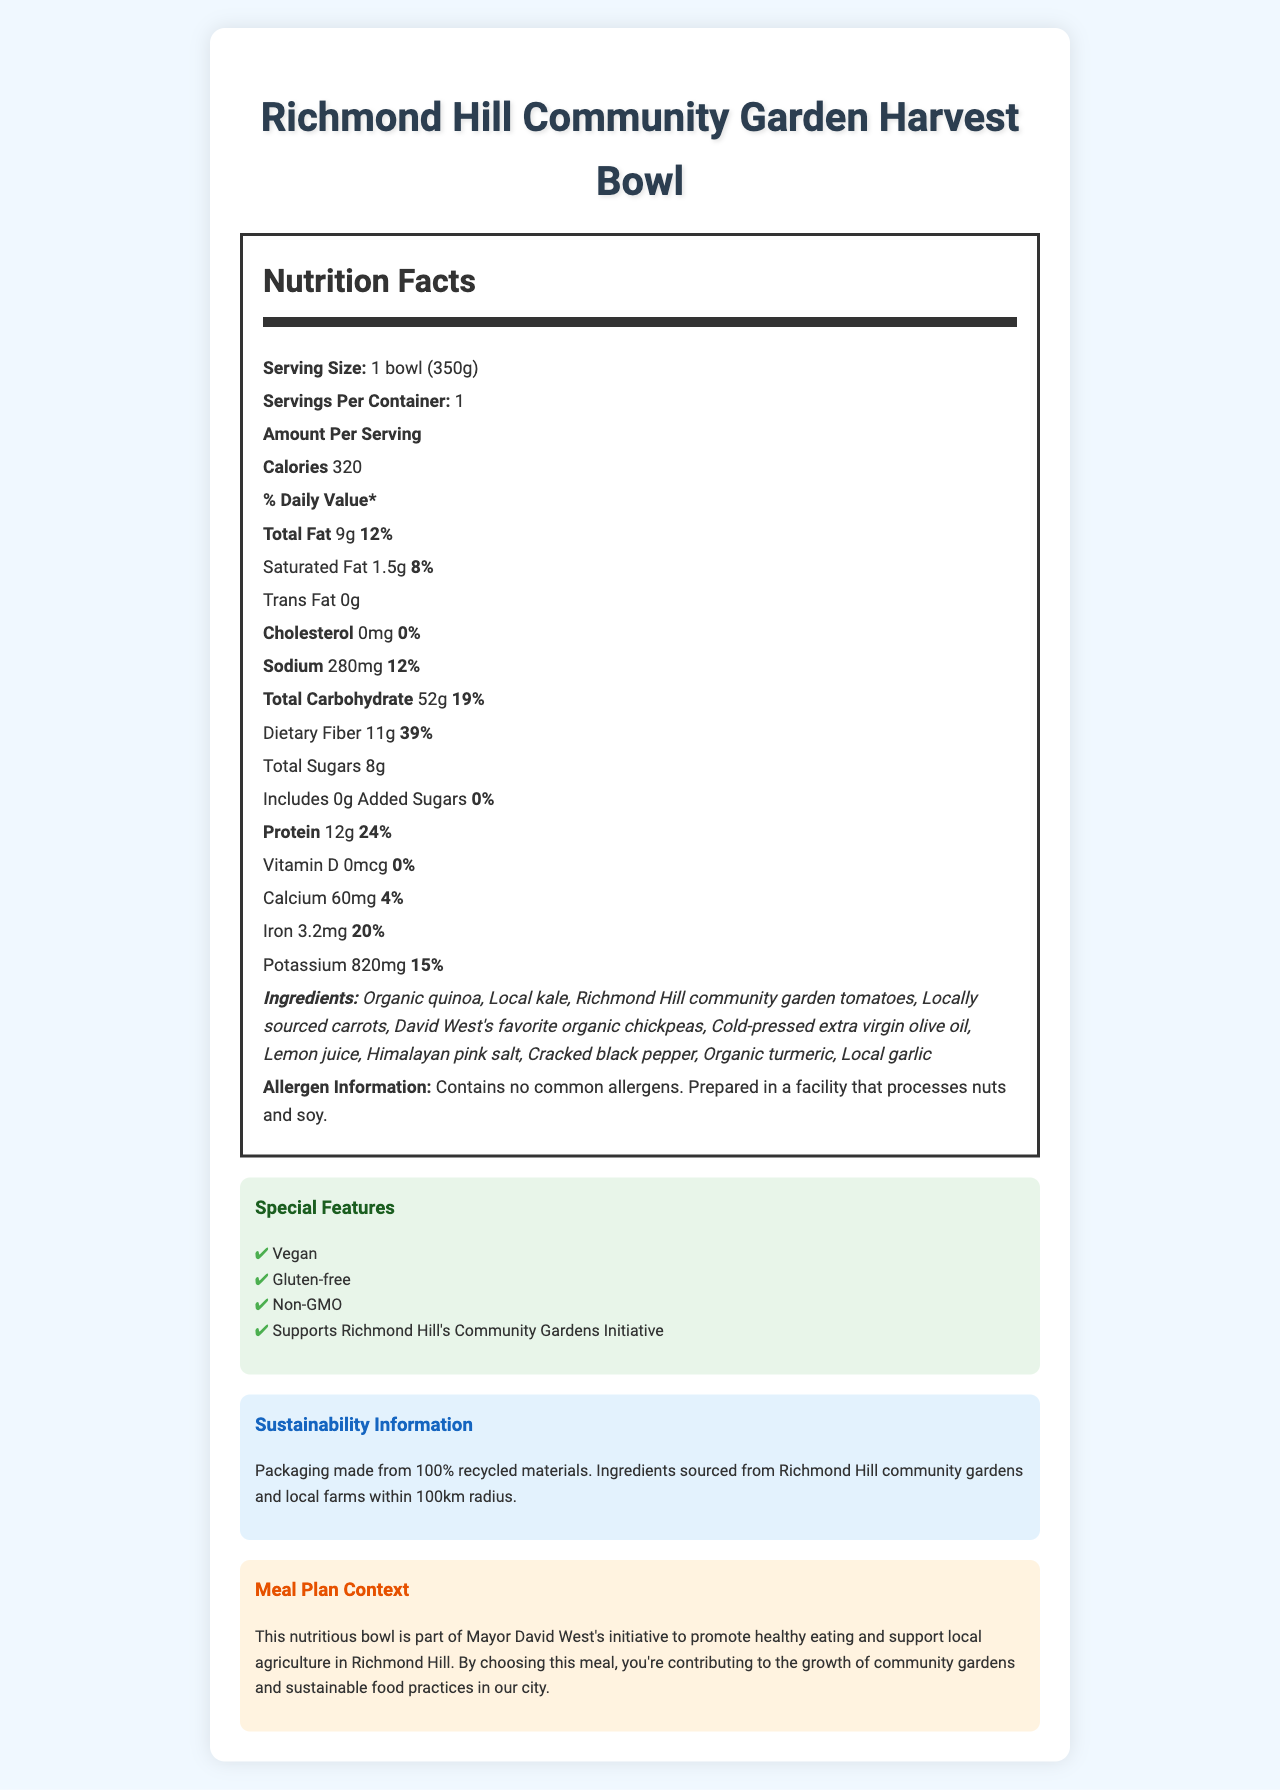what is the serving size for the Richmond Hill Community Garden Harvest Bowl? The serving size is listed in the nutrition facts section as "1 bowl (350g)".
Answer: 1 bowl (350g) how many calories are in one serving of the Harvest Bowl? The number of calories is stated as 320 in the nutrition facts.
Answer: 320 what percentage of the daily value of dietary fiber does one serving of the Harvest Bowl provide? The nutrition facts label indicates that the dietary fiber daily value percentage is 39%.
Answer: 39% list three ingredients used in the Harvest Bowl. Three of the listed ingredients are Organic quinoa, Local kale, and Richmond Hill community garden tomatoes.
Answer: Organic quinoa, Local kale, Richmond Hill community garden tomatoes what is the total carbohydrate content in one serving? The nutrition facts state that one serving contains 52g of total carbohydrates.
Answer: 52g does the Harvest Bowl contain any added sugars? The label indicates that the amount of added sugars is 0g.
Answer: No what are the special features of the Harvest Bowl? The document lists these special features in a dedicated section.
Answer: Vegan, Gluten-free, Non-GMO, Supports Richmond Hill's Community Gardens Initiative how much protein does one serving of the Harvest Bowl contain? A. 24g B. 12g C. 9g D. 3g The protein content per serving is listed as 12g.
Answer: B what is the amount of sodium in one serving of the Harvest Bowl? A. 150mg B. 280mg C. 50mg D. 500mg The amount of sodium per serving is 280mg.
Answer: B is the meal gluten-free? The special features section indicates that the meal is gluten-free.
Answer: Yes summarize the document's main idea. The document provides comprehensive information about the product, its nutritional content, ingredients, and the broader context of supporting local community gardens in Richmond Hill.
Answer: The Richmond Hill Community Garden Harvest Bowl is a healthy, sustainable, and locally-sourced meal that supports community gardens. It provides detailed nutritional information, ingredients, and special features such as being vegan, gluten-free, and non-GMO. who is the meal plan designed to support? The meal plan context states that the meal supports the Richmond Hill's Community Gardens Initiative.
Answer: Richmond Hill's Community Gardens Initiative can this meal be enjoyed by someone with a nut allergy? The allergen information mentions that it is prepared in a facility that processes nuts, so it might not be safe for someone with a nut allergy, but this detail is not entirely conclusive without further context.
Answer: Not enough information 